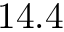<formula> <loc_0><loc_0><loc_500><loc_500>1 4 . 4</formula> 